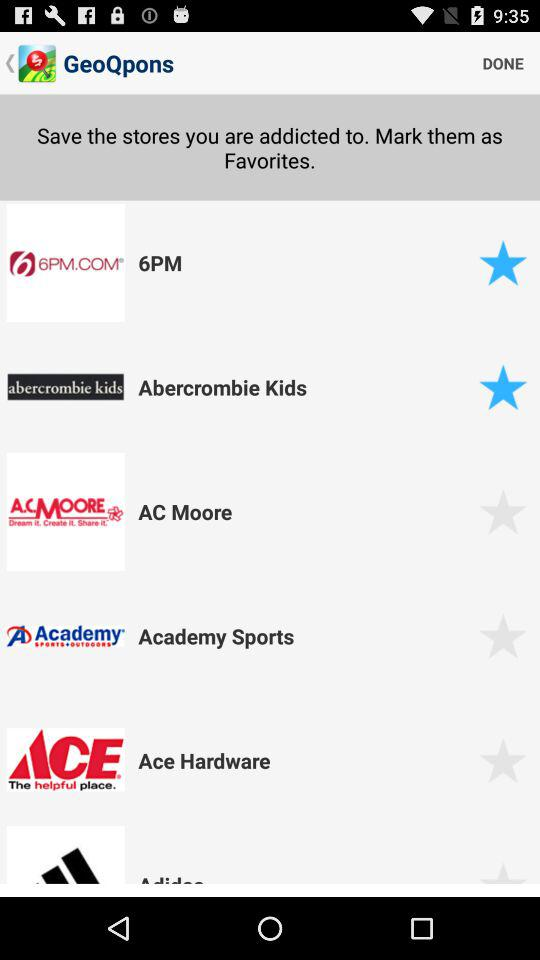Which stores are marked as favorites? The stores that are marked as favorites are "6PM" and "Abercrombie Kids". 